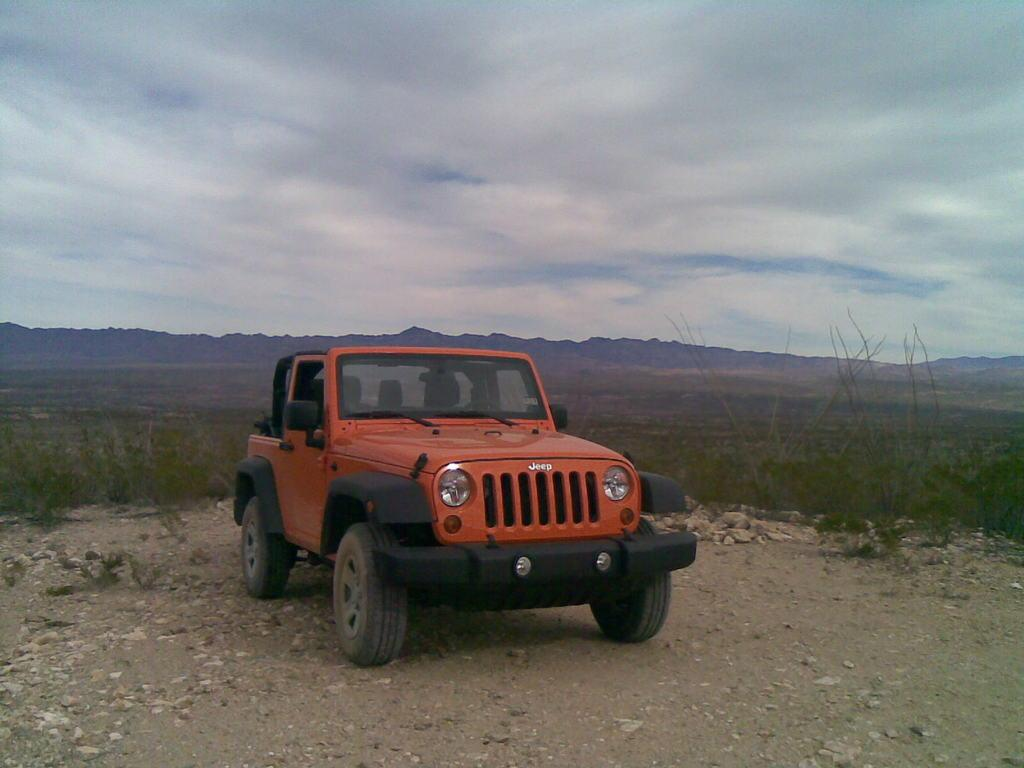What vehicle is in the image? There is a jeep in the image. What type of terrain is visible at the bottom of the image? Grass is present at the bottom of the image. What type of surface is visible in the image? Stones are visible on the surface. What type of vegetation can be seen in the background of the image? There are trees in the background of the image. What type of geographical feature is visible in the background of the image? Mountains are visible in the background of the image. What is visible in the sky in the background of the image? The sky is visible in the background of the image. What type of linen is draped over the mountains in the image? There is no linen present in the image; the mountains are visible in their natural state. 